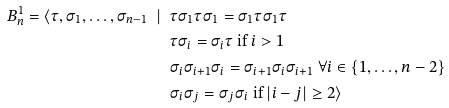<formula> <loc_0><loc_0><loc_500><loc_500>B _ { n } ^ { 1 } = \langle \tau , \sigma _ { 1 } , \dots , \sigma _ { n - 1 } \ | \ & \tau \sigma _ { 1 } \tau \sigma _ { 1 } = \sigma _ { 1 } \tau \sigma _ { 1 } \tau \\ & \tau \sigma _ { i } = \sigma _ { i } \tau \text { if } i > 1 \\ & \sigma _ { i } \sigma _ { i + 1 } \sigma _ { i } = \sigma _ { i + 1 } \sigma _ { i } \sigma _ { i + 1 } \ \forall i \in \{ 1 , \dots , n - 2 \} \\ & \sigma _ { i } \sigma _ { j } = \sigma _ { j } \sigma _ { i } \text { if } | i - j | \geq 2 \rangle</formula> 